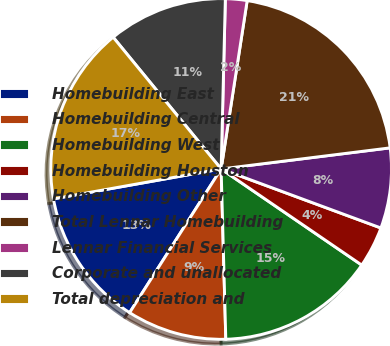Convert chart. <chart><loc_0><loc_0><loc_500><loc_500><pie_chart><fcel>Homebuilding East<fcel>Homebuilding Central<fcel>Homebuilding West<fcel>Homebuilding Houston<fcel>Homebuilding Other<fcel>Total Lennar Homebuilding<fcel>Lennar Financial Services<fcel>Corporate and unallocated<fcel>Total depreciation and<nl><fcel>13.17%<fcel>9.46%<fcel>15.02%<fcel>3.91%<fcel>7.61%<fcel>20.58%<fcel>2.05%<fcel>11.32%<fcel>16.88%<nl></chart> 